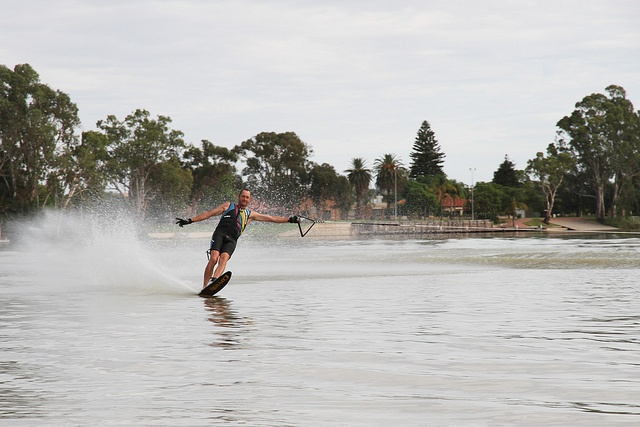Describe the objects in this image and their specific colors. I can see people in lightgray, black, brown, and maroon tones in this image. 